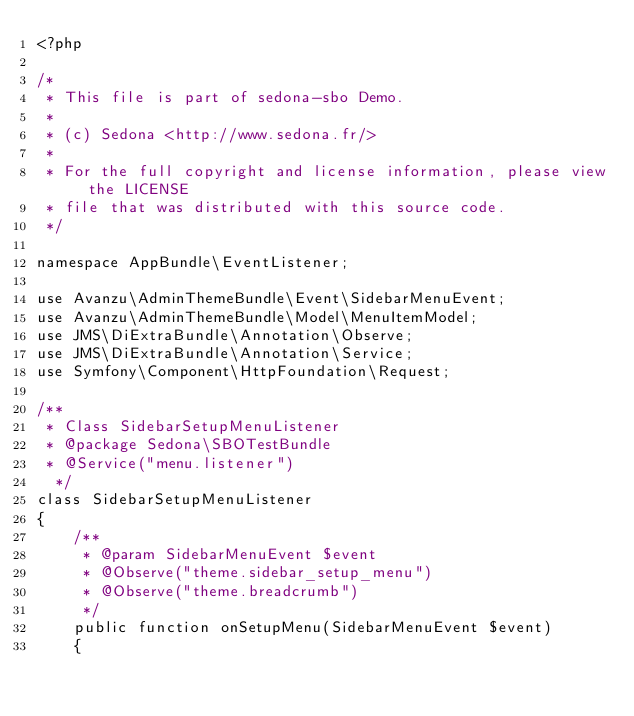<code> <loc_0><loc_0><loc_500><loc_500><_PHP_><?php

/*
 * This file is part of sedona-sbo Demo.
 *
 * (c) Sedona <http://www.sedona.fr/>
 *
 * For the full copyright and license information, please view the LICENSE
 * file that was distributed with this source code.
 */

namespace AppBundle\EventListener;

use Avanzu\AdminThemeBundle\Event\SidebarMenuEvent;
use Avanzu\AdminThemeBundle\Model\MenuItemModel;
use JMS\DiExtraBundle\Annotation\Observe;
use JMS\DiExtraBundle\Annotation\Service;
use Symfony\Component\HttpFoundation\Request;

/**
 * Class SidebarSetupMenuListener
 * @package Sedona\SBOTestBundle
 * @Service("menu.listener")
  */
class SidebarSetupMenuListener
{
    /**
     * @param SidebarMenuEvent $event
     * @Observe("theme.sidebar_setup_menu")
     * @Observe("theme.breadcrumb")
     */
    public function onSetupMenu(SidebarMenuEvent $event)
    {</code> 